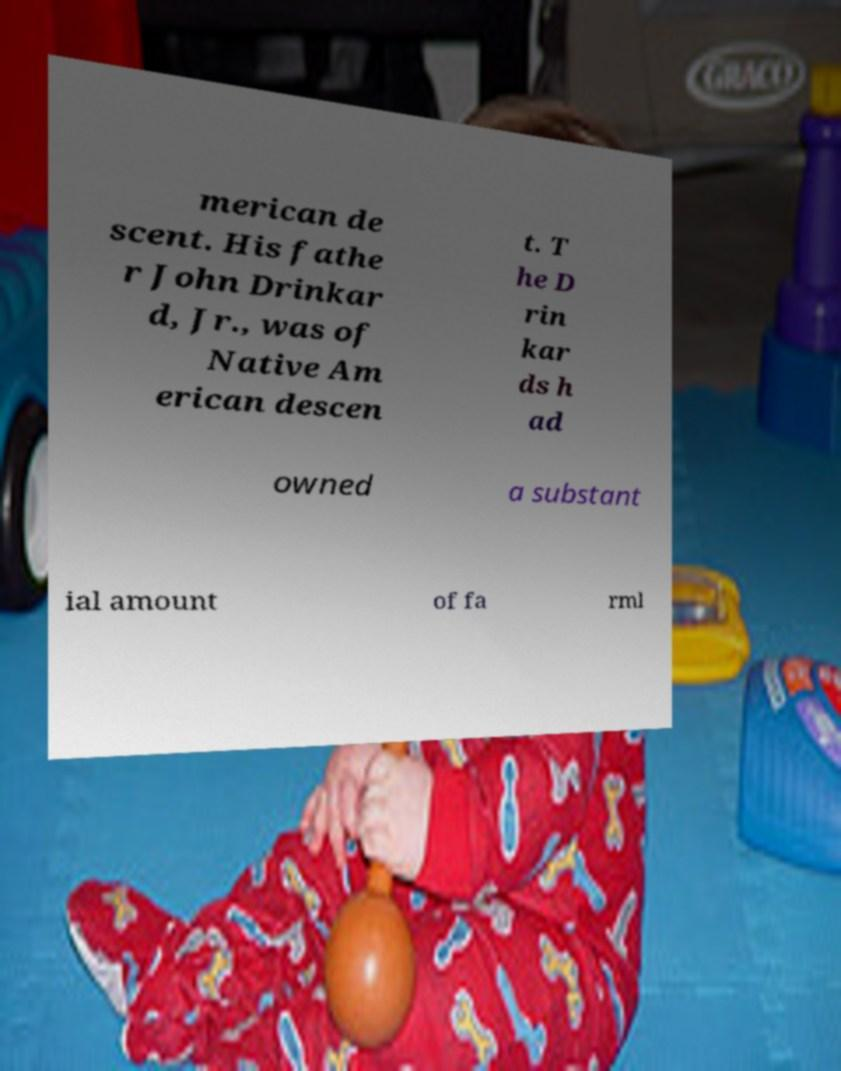I need the written content from this picture converted into text. Can you do that? merican de scent. His fathe r John Drinkar d, Jr., was of Native Am erican descen t. T he D rin kar ds h ad owned a substant ial amount of fa rml 